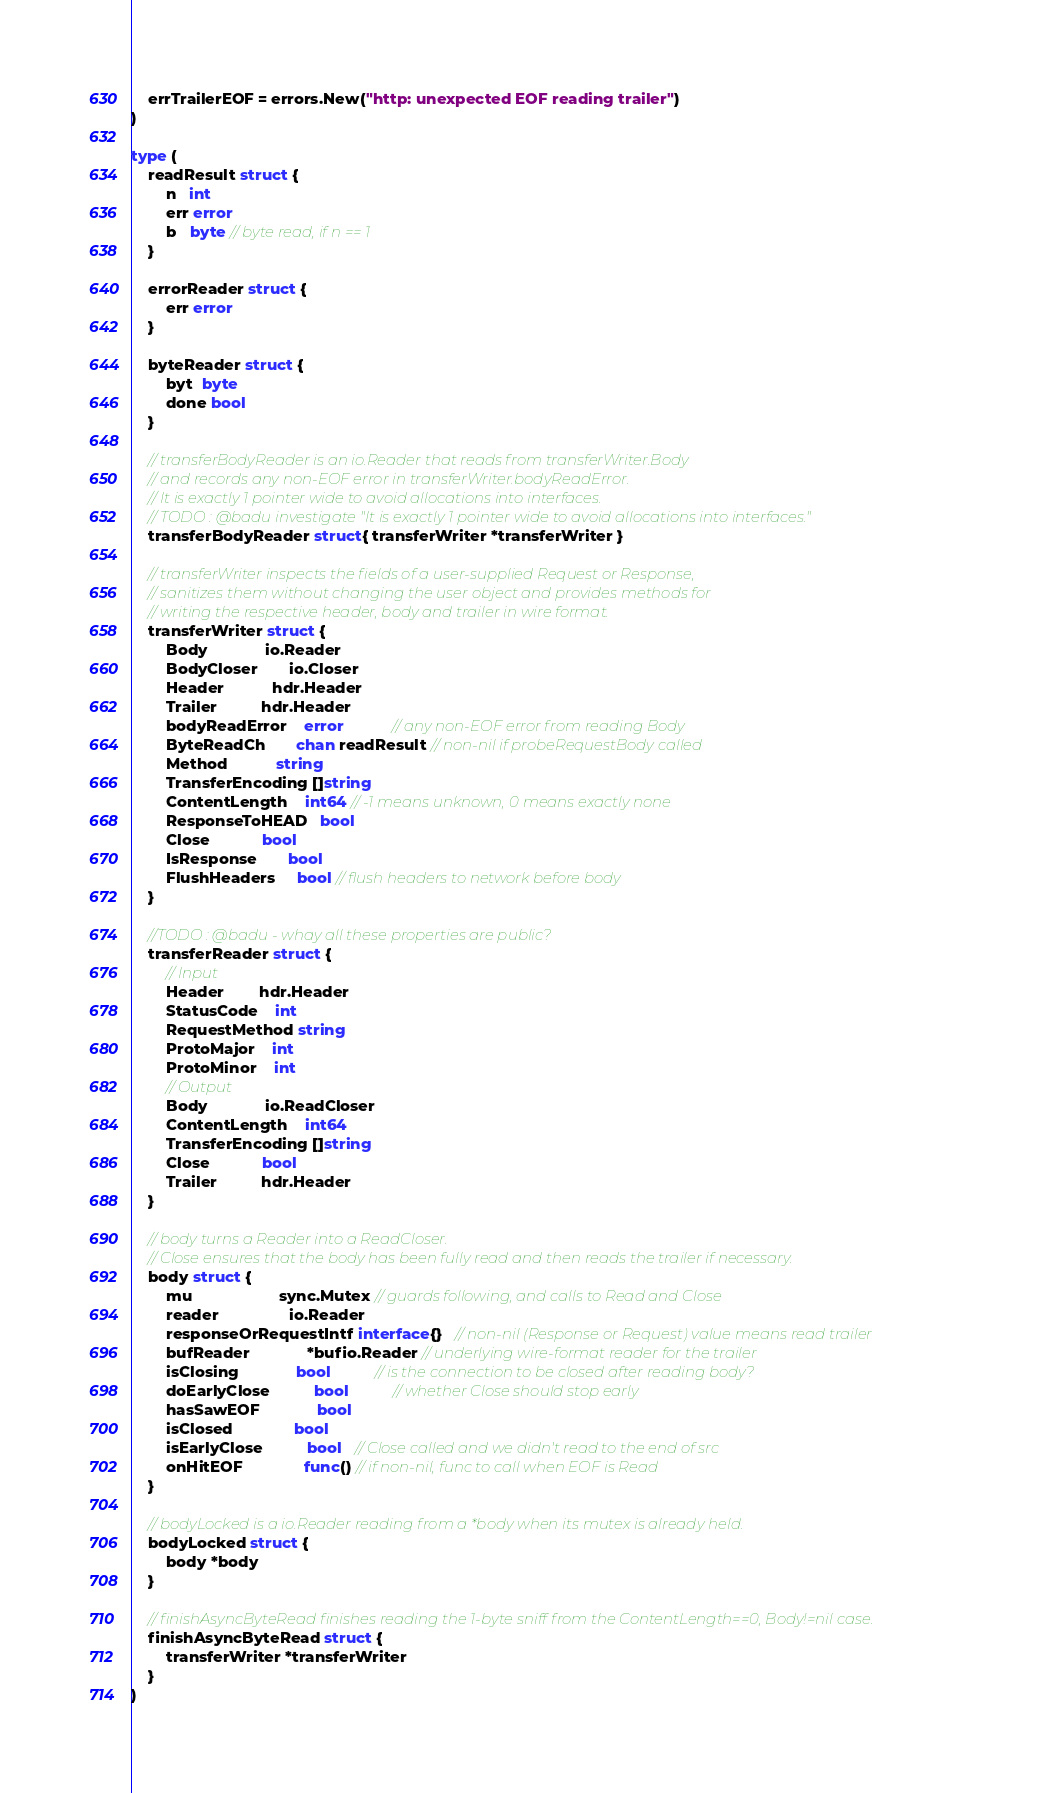Convert code to text. <code><loc_0><loc_0><loc_500><loc_500><_Go_>
	errTrailerEOF = errors.New("http: unexpected EOF reading trailer")
)

type (
	readResult struct {
		n   int
		err error
		b   byte // byte read, if n == 1
	}

	errorReader struct {
		err error
	}

	byteReader struct {
		byt  byte
		done bool
	}

	// transferBodyReader is an io.Reader that reads from transferWriter.Body
	// and records any non-EOF error in transferWriter.bodyReadError.
	// It is exactly 1 pointer wide to avoid allocations into interfaces.
	// TODO : @badu investigate "It is exactly 1 pointer wide to avoid allocations into interfaces."
	transferBodyReader struct{ transferWriter *transferWriter }

	// transferWriter inspects the fields of a user-supplied Request or Response,
	// sanitizes them without changing the user object and provides methods for
	// writing the respective header, body and trailer in wire format.
	transferWriter struct {
		Body             io.Reader
		BodyCloser       io.Closer
		Header           hdr.Header
		Trailer          hdr.Header
		bodyReadError    error           // any non-EOF error from reading Body
		ByteReadCh       chan readResult // non-nil if probeRequestBody called
		Method           string
		TransferEncoding []string
		ContentLength    int64 // -1 means unknown, 0 means exactly none
		ResponseToHEAD   bool
		Close            bool
		IsResponse       bool
		FlushHeaders     bool // flush headers to network before body
	}

	//TODO : @badu - whay all these properties are public?
	transferReader struct {
		// Input
		Header        hdr.Header
		StatusCode    int
		RequestMethod string
		ProtoMajor    int
		ProtoMinor    int
		// Output
		Body             io.ReadCloser
		ContentLength    int64
		TransferEncoding []string
		Close            bool
		Trailer          hdr.Header
	}

	// body turns a Reader into a ReadCloser.
	// Close ensures that the body has been fully read and then reads the trailer if necessary.
	body struct {
		mu                    sync.Mutex // guards following, and calls to Read and Close
		reader                io.Reader
		responseOrRequestIntf interface{}   // non-nil (Response or Request) value means read trailer
		bufReader             *bufio.Reader // underlying wire-format reader for the trailer
		isClosing             bool          // is the connection to be closed after reading body?
		doEarlyClose          bool          // whether Close should stop early
		hasSawEOF             bool
		isClosed              bool
		isEarlyClose          bool   // Close called and we didn't read to the end of src
		onHitEOF              func() // if non-nil, func to call when EOF is Read
	}

	// bodyLocked is a io.Reader reading from a *body when its mutex is already held.
	bodyLocked struct {
		body *body
	}

	// finishAsyncByteRead finishes reading the 1-byte sniff from the ContentLength==0, Body!=nil case.
	finishAsyncByteRead struct {
		transferWriter *transferWriter
	}
)
</code> 